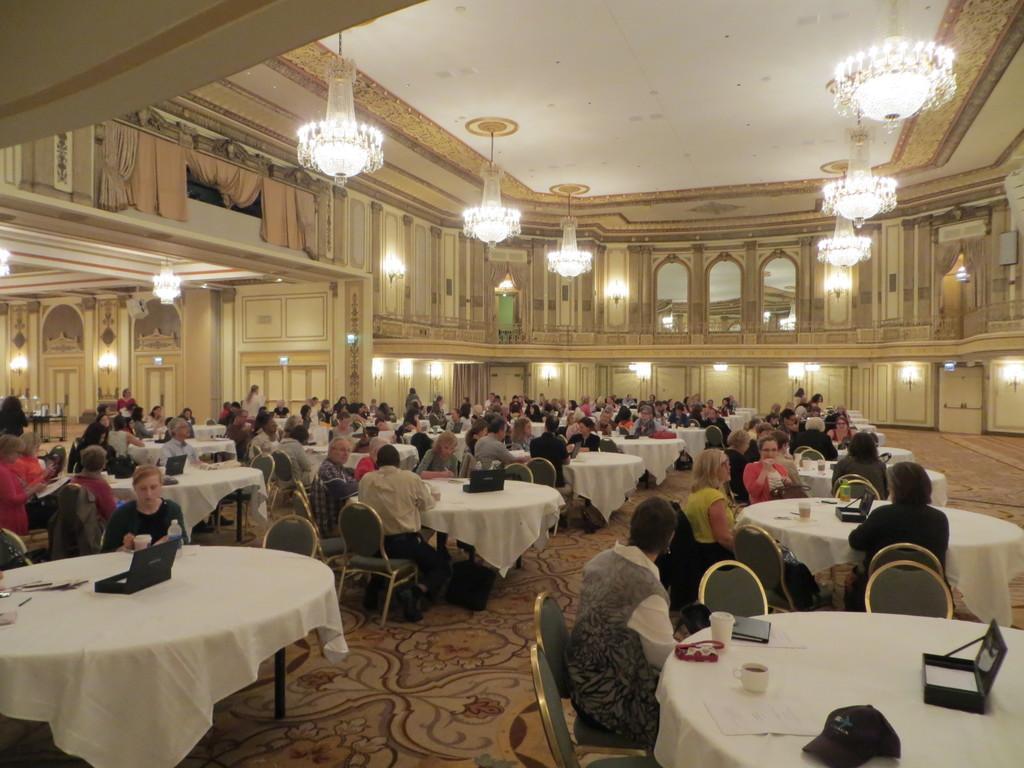How would you summarize this image in a sentence or two? In this hall there are many people in the chairs around the table. On this some boxes were placed. There are some chandeliers to the ceiling. In the background there some lights and a windows here. 